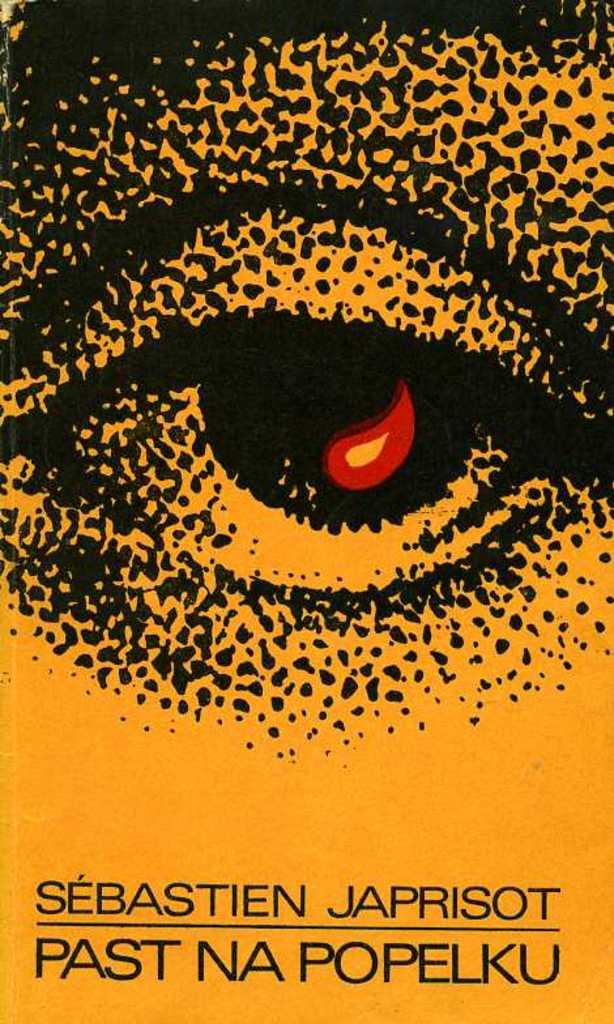<image>
Offer a succinct explanation of the picture presented. A poster for Past Na Popelku shows an eye with fire in the middle 